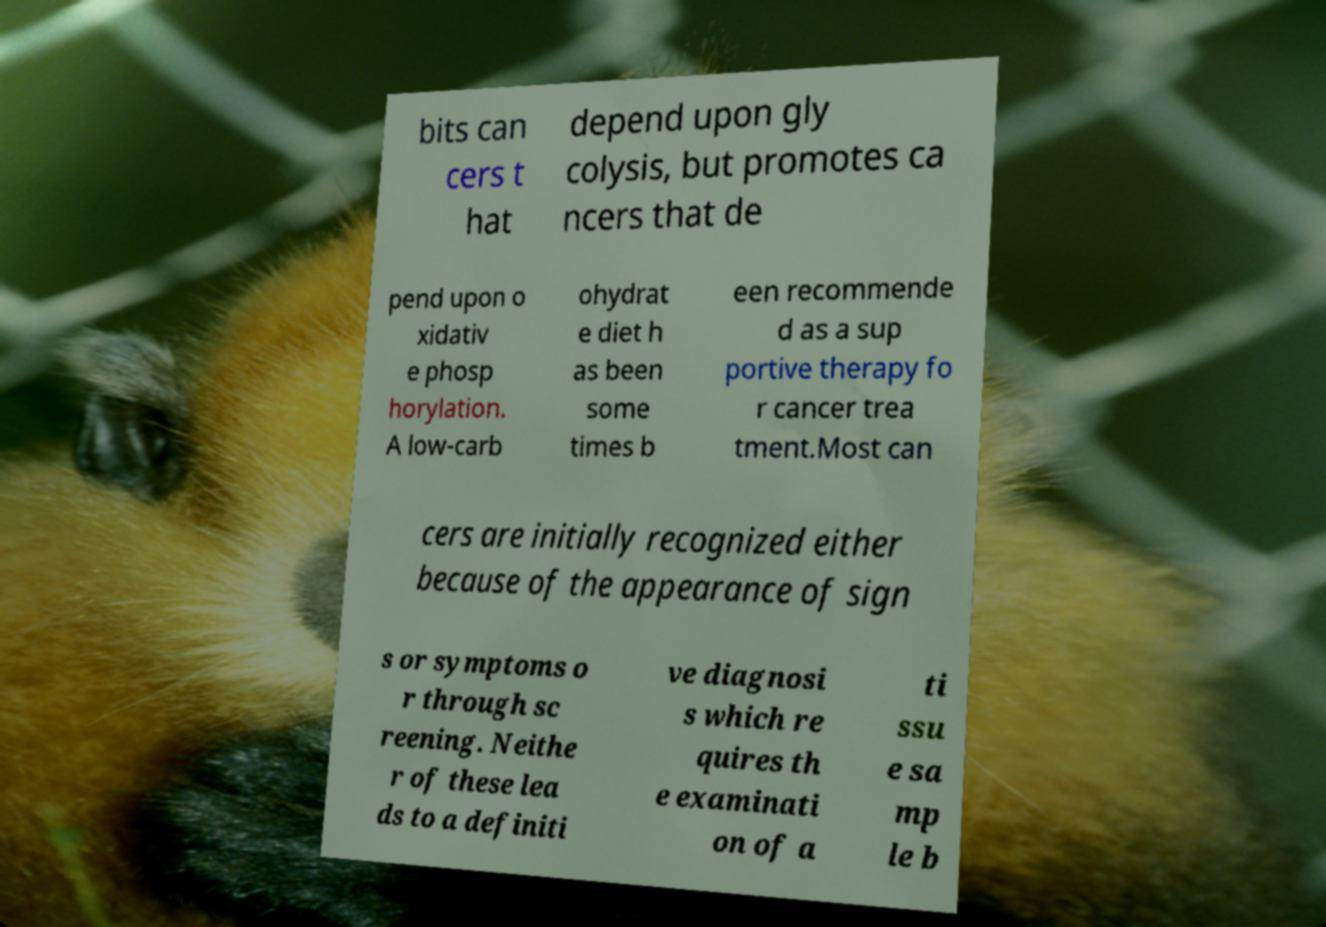There's text embedded in this image that I need extracted. Can you transcribe it verbatim? bits can cers t hat depend upon gly colysis, but promotes ca ncers that de pend upon o xidativ e phosp horylation. A low-carb ohydrat e diet h as been some times b een recommende d as a sup portive therapy fo r cancer trea tment.Most can cers are initially recognized either because of the appearance of sign s or symptoms o r through sc reening. Neithe r of these lea ds to a definiti ve diagnosi s which re quires th e examinati on of a ti ssu e sa mp le b 